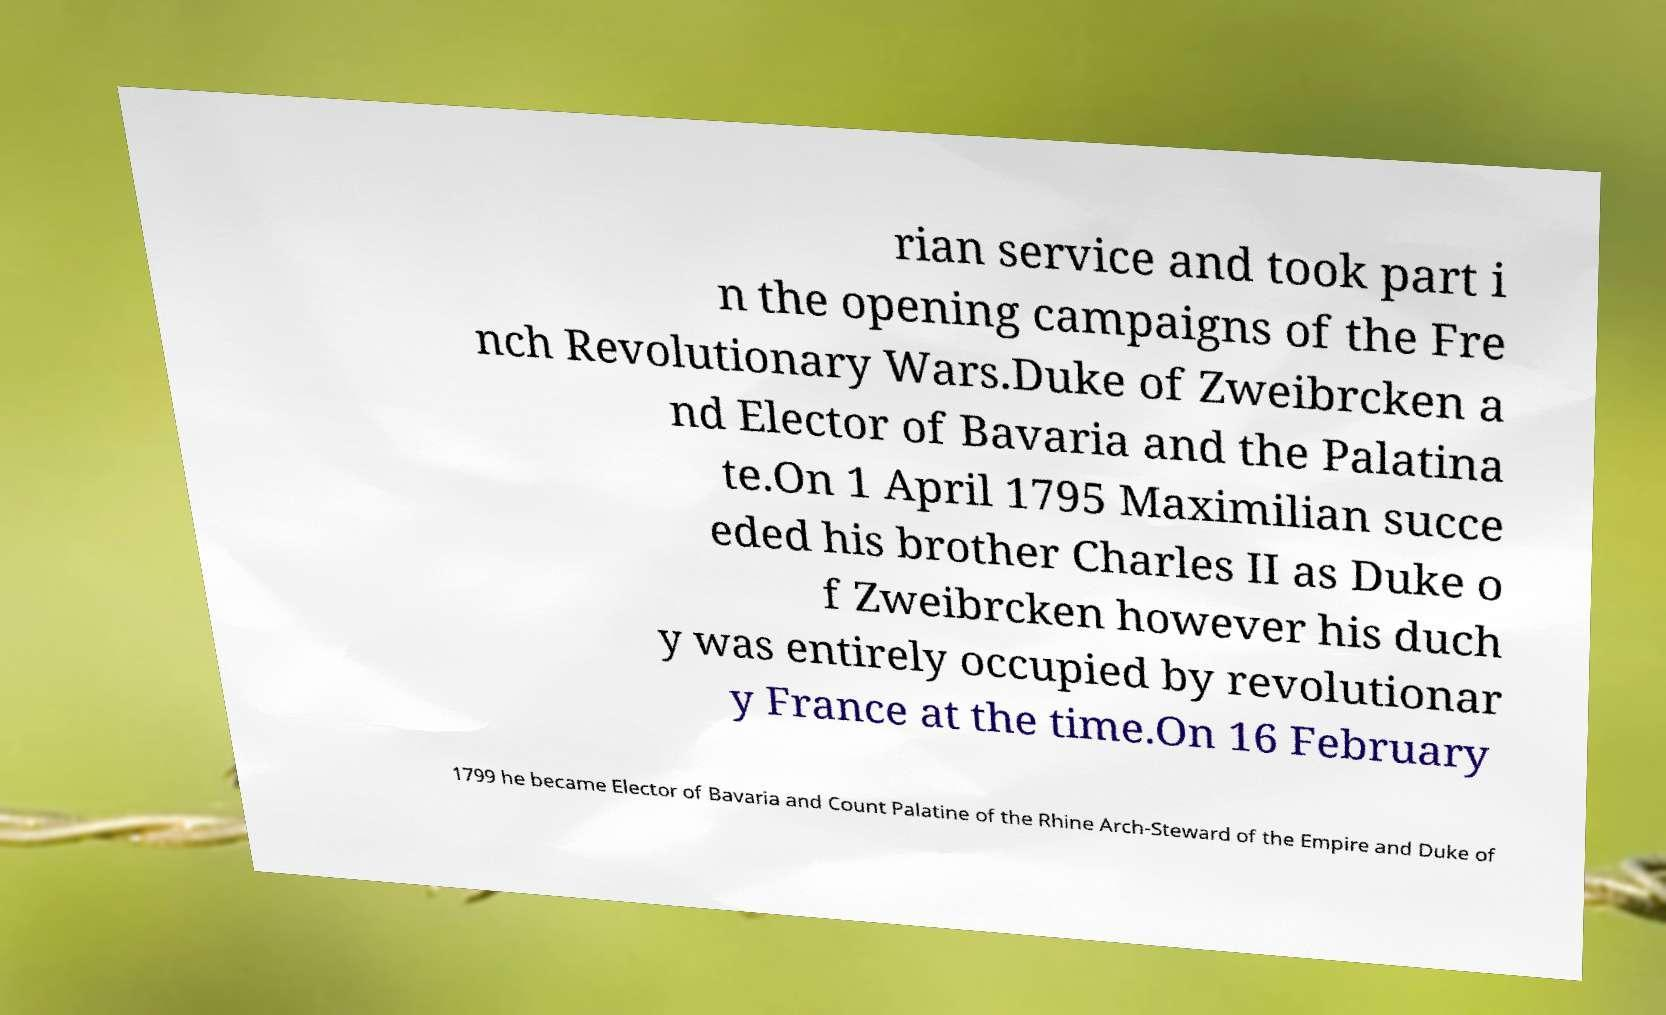Can you accurately transcribe the text from the provided image for me? rian service and took part i n the opening campaigns of the Fre nch Revolutionary Wars.Duke of Zweibrcken a nd Elector of Bavaria and the Palatina te.On 1 April 1795 Maximilian succe eded his brother Charles II as Duke o f Zweibrcken however his duch y was entirely occupied by revolutionar y France at the time.On 16 February 1799 he became Elector of Bavaria and Count Palatine of the Rhine Arch-Steward of the Empire and Duke of 